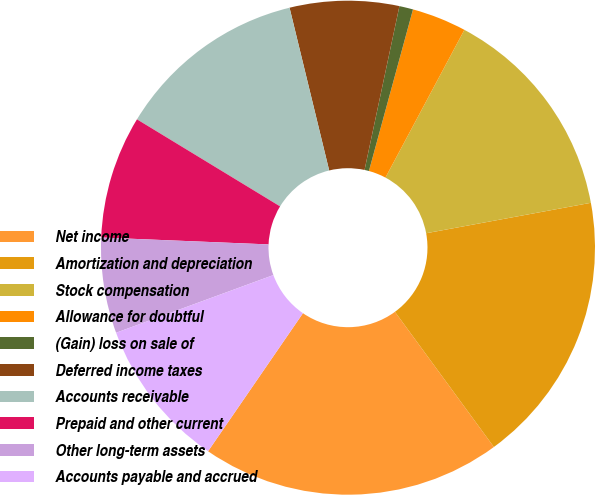Convert chart to OTSL. <chart><loc_0><loc_0><loc_500><loc_500><pie_chart><fcel>Net income<fcel>Amortization and depreciation<fcel>Stock compensation<fcel>Allowance for doubtful<fcel>(Gain) loss on sale of<fcel>Deferred income taxes<fcel>Accounts receivable<fcel>Prepaid and other current<fcel>Other long-term assets<fcel>Accounts payable and accrued<nl><fcel>19.64%<fcel>17.85%<fcel>14.28%<fcel>3.57%<fcel>0.9%<fcel>7.14%<fcel>12.5%<fcel>8.04%<fcel>6.25%<fcel>9.82%<nl></chart> 